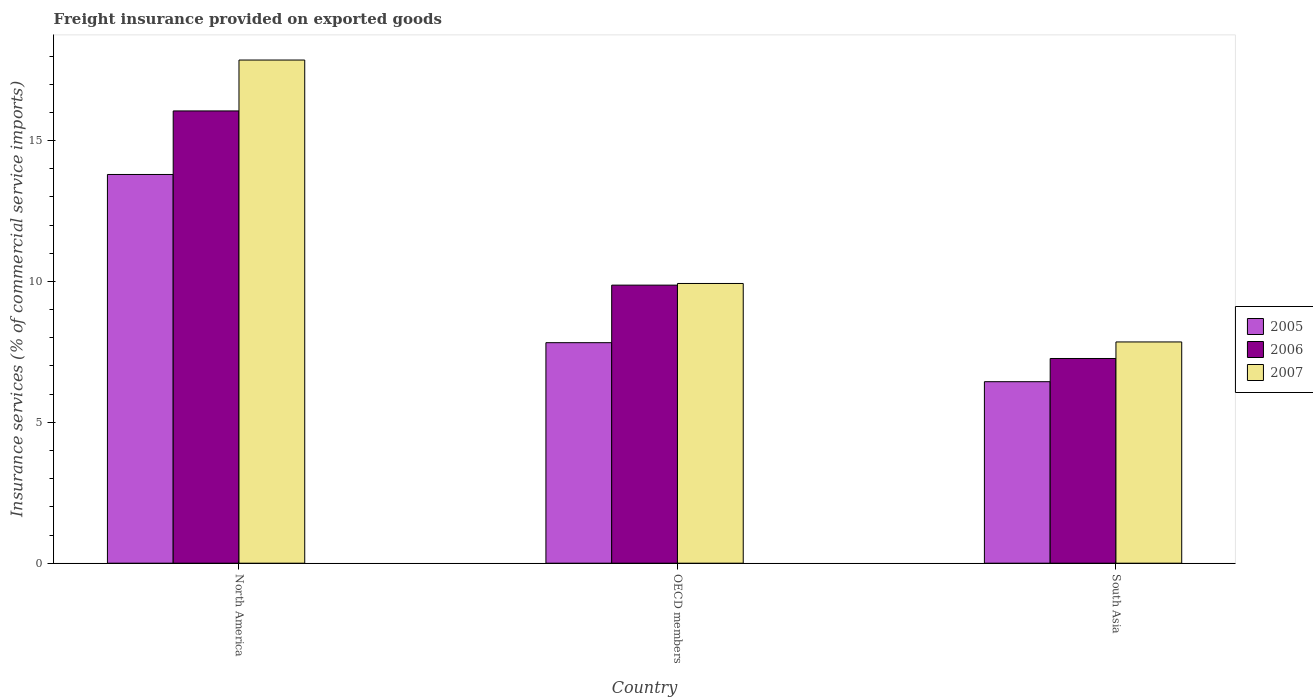How many different coloured bars are there?
Give a very brief answer. 3. Are the number of bars on each tick of the X-axis equal?
Ensure brevity in your answer.  Yes. In how many cases, is the number of bars for a given country not equal to the number of legend labels?
Provide a short and direct response. 0. What is the freight insurance provided on exported goods in 2005 in OECD members?
Offer a terse response. 7.83. Across all countries, what is the maximum freight insurance provided on exported goods in 2006?
Offer a terse response. 16.05. Across all countries, what is the minimum freight insurance provided on exported goods in 2006?
Offer a very short reply. 7.27. In which country was the freight insurance provided on exported goods in 2006 maximum?
Your answer should be very brief. North America. What is the total freight insurance provided on exported goods in 2006 in the graph?
Offer a very short reply. 33.19. What is the difference between the freight insurance provided on exported goods in 2006 in North America and that in OECD members?
Provide a short and direct response. 6.18. What is the difference between the freight insurance provided on exported goods in 2006 in North America and the freight insurance provided on exported goods in 2005 in South Asia?
Your answer should be very brief. 9.61. What is the average freight insurance provided on exported goods in 2005 per country?
Ensure brevity in your answer.  9.36. What is the difference between the freight insurance provided on exported goods of/in 2006 and freight insurance provided on exported goods of/in 2007 in South Asia?
Provide a short and direct response. -0.59. What is the ratio of the freight insurance provided on exported goods in 2005 in North America to that in OECD members?
Give a very brief answer. 1.76. Is the freight insurance provided on exported goods in 2005 in OECD members less than that in South Asia?
Your response must be concise. No. Is the difference between the freight insurance provided on exported goods in 2006 in North America and OECD members greater than the difference between the freight insurance provided on exported goods in 2007 in North America and OECD members?
Provide a short and direct response. No. What is the difference between the highest and the second highest freight insurance provided on exported goods in 2007?
Offer a terse response. 7.93. What is the difference between the highest and the lowest freight insurance provided on exported goods in 2007?
Keep it short and to the point. 10.01. In how many countries, is the freight insurance provided on exported goods in 2005 greater than the average freight insurance provided on exported goods in 2005 taken over all countries?
Provide a succinct answer. 1. What does the 1st bar from the left in North America represents?
Give a very brief answer. 2005. What does the 2nd bar from the right in South Asia represents?
Your answer should be very brief. 2006. Is it the case that in every country, the sum of the freight insurance provided on exported goods in 2006 and freight insurance provided on exported goods in 2005 is greater than the freight insurance provided on exported goods in 2007?
Provide a short and direct response. Yes. How many bars are there?
Ensure brevity in your answer.  9. Are all the bars in the graph horizontal?
Offer a terse response. No. What is the title of the graph?
Provide a short and direct response. Freight insurance provided on exported goods. Does "1976" appear as one of the legend labels in the graph?
Provide a short and direct response. No. What is the label or title of the Y-axis?
Offer a terse response. Insurance services (% of commercial service imports). What is the Insurance services (% of commercial service imports) of 2005 in North America?
Offer a terse response. 13.8. What is the Insurance services (% of commercial service imports) of 2006 in North America?
Offer a very short reply. 16.05. What is the Insurance services (% of commercial service imports) of 2007 in North America?
Your response must be concise. 17.86. What is the Insurance services (% of commercial service imports) in 2005 in OECD members?
Make the answer very short. 7.83. What is the Insurance services (% of commercial service imports) in 2006 in OECD members?
Ensure brevity in your answer.  9.87. What is the Insurance services (% of commercial service imports) in 2007 in OECD members?
Offer a terse response. 9.93. What is the Insurance services (% of commercial service imports) of 2005 in South Asia?
Offer a very short reply. 6.44. What is the Insurance services (% of commercial service imports) of 2006 in South Asia?
Your answer should be compact. 7.27. What is the Insurance services (% of commercial service imports) in 2007 in South Asia?
Your answer should be very brief. 7.85. Across all countries, what is the maximum Insurance services (% of commercial service imports) in 2005?
Keep it short and to the point. 13.8. Across all countries, what is the maximum Insurance services (% of commercial service imports) in 2006?
Ensure brevity in your answer.  16.05. Across all countries, what is the maximum Insurance services (% of commercial service imports) of 2007?
Provide a short and direct response. 17.86. Across all countries, what is the minimum Insurance services (% of commercial service imports) in 2005?
Your answer should be compact. 6.44. Across all countries, what is the minimum Insurance services (% of commercial service imports) in 2006?
Your response must be concise. 7.27. Across all countries, what is the minimum Insurance services (% of commercial service imports) of 2007?
Your answer should be very brief. 7.85. What is the total Insurance services (% of commercial service imports) of 2005 in the graph?
Ensure brevity in your answer.  28.07. What is the total Insurance services (% of commercial service imports) of 2006 in the graph?
Provide a short and direct response. 33.19. What is the total Insurance services (% of commercial service imports) in 2007 in the graph?
Keep it short and to the point. 35.64. What is the difference between the Insurance services (% of commercial service imports) of 2005 in North America and that in OECD members?
Make the answer very short. 5.97. What is the difference between the Insurance services (% of commercial service imports) in 2006 in North America and that in OECD members?
Make the answer very short. 6.18. What is the difference between the Insurance services (% of commercial service imports) of 2007 in North America and that in OECD members?
Your answer should be very brief. 7.93. What is the difference between the Insurance services (% of commercial service imports) in 2005 in North America and that in South Asia?
Offer a very short reply. 7.35. What is the difference between the Insurance services (% of commercial service imports) of 2006 in North America and that in South Asia?
Make the answer very short. 8.79. What is the difference between the Insurance services (% of commercial service imports) of 2007 in North America and that in South Asia?
Keep it short and to the point. 10.01. What is the difference between the Insurance services (% of commercial service imports) in 2005 in OECD members and that in South Asia?
Your answer should be very brief. 1.38. What is the difference between the Insurance services (% of commercial service imports) of 2006 in OECD members and that in South Asia?
Your answer should be very brief. 2.6. What is the difference between the Insurance services (% of commercial service imports) of 2007 in OECD members and that in South Asia?
Ensure brevity in your answer.  2.08. What is the difference between the Insurance services (% of commercial service imports) of 2005 in North America and the Insurance services (% of commercial service imports) of 2006 in OECD members?
Keep it short and to the point. 3.93. What is the difference between the Insurance services (% of commercial service imports) of 2005 in North America and the Insurance services (% of commercial service imports) of 2007 in OECD members?
Your answer should be compact. 3.87. What is the difference between the Insurance services (% of commercial service imports) in 2006 in North America and the Insurance services (% of commercial service imports) in 2007 in OECD members?
Make the answer very short. 6.12. What is the difference between the Insurance services (% of commercial service imports) in 2005 in North America and the Insurance services (% of commercial service imports) in 2006 in South Asia?
Make the answer very short. 6.53. What is the difference between the Insurance services (% of commercial service imports) in 2005 in North America and the Insurance services (% of commercial service imports) in 2007 in South Asia?
Provide a succinct answer. 5.94. What is the difference between the Insurance services (% of commercial service imports) of 2006 in North America and the Insurance services (% of commercial service imports) of 2007 in South Asia?
Your answer should be very brief. 8.2. What is the difference between the Insurance services (% of commercial service imports) of 2005 in OECD members and the Insurance services (% of commercial service imports) of 2006 in South Asia?
Offer a terse response. 0.56. What is the difference between the Insurance services (% of commercial service imports) in 2005 in OECD members and the Insurance services (% of commercial service imports) in 2007 in South Asia?
Give a very brief answer. -0.03. What is the difference between the Insurance services (% of commercial service imports) of 2006 in OECD members and the Insurance services (% of commercial service imports) of 2007 in South Asia?
Give a very brief answer. 2.02. What is the average Insurance services (% of commercial service imports) in 2005 per country?
Your response must be concise. 9.36. What is the average Insurance services (% of commercial service imports) of 2006 per country?
Provide a short and direct response. 11.06. What is the average Insurance services (% of commercial service imports) of 2007 per country?
Offer a very short reply. 11.88. What is the difference between the Insurance services (% of commercial service imports) in 2005 and Insurance services (% of commercial service imports) in 2006 in North America?
Your answer should be very brief. -2.26. What is the difference between the Insurance services (% of commercial service imports) in 2005 and Insurance services (% of commercial service imports) in 2007 in North America?
Your response must be concise. -4.06. What is the difference between the Insurance services (% of commercial service imports) of 2006 and Insurance services (% of commercial service imports) of 2007 in North America?
Your answer should be compact. -1.81. What is the difference between the Insurance services (% of commercial service imports) in 2005 and Insurance services (% of commercial service imports) in 2006 in OECD members?
Provide a short and direct response. -2.04. What is the difference between the Insurance services (% of commercial service imports) in 2005 and Insurance services (% of commercial service imports) in 2007 in OECD members?
Provide a short and direct response. -2.1. What is the difference between the Insurance services (% of commercial service imports) of 2006 and Insurance services (% of commercial service imports) of 2007 in OECD members?
Make the answer very short. -0.06. What is the difference between the Insurance services (% of commercial service imports) of 2005 and Insurance services (% of commercial service imports) of 2006 in South Asia?
Offer a very short reply. -0.82. What is the difference between the Insurance services (% of commercial service imports) of 2005 and Insurance services (% of commercial service imports) of 2007 in South Asia?
Your answer should be compact. -1.41. What is the difference between the Insurance services (% of commercial service imports) in 2006 and Insurance services (% of commercial service imports) in 2007 in South Asia?
Your answer should be very brief. -0.59. What is the ratio of the Insurance services (% of commercial service imports) of 2005 in North America to that in OECD members?
Ensure brevity in your answer.  1.76. What is the ratio of the Insurance services (% of commercial service imports) in 2006 in North America to that in OECD members?
Give a very brief answer. 1.63. What is the ratio of the Insurance services (% of commercial service imports) of 2007 in North America to that in OECD members?
Give a very brief answer. 1.8. What is the ratio of the Insurance services (% of commercial service imports) of 2005 in North America to that in South Asia?
Your response must be concise. 2.14. What is the ratio of the Insurance services (% of commercial service imports) in 2006 in North America to that in South Asia?
Offer a terse response. 2.21. What is the ratio of the Insurance services (% of commercial service imports) of 2007 in North America to that in South Asia?
Offer a terse response. 2.27. What is the ratio of the Insurance services (% of commercial service imports) of 2005 in OECD members to that in South Asia?
Offer a very short reply. 1.21. What is the ratio of the Insurance services (% of commercial service imports) in 2006 in OECD members to that in South Asia?
Offer a very short reply. 1.36. What is the ratio of the Insurance services (% of commercial service imports) in 2007 in OECD members to that in South Asia?
Offer a very short reply. 1.26. What is the difference between the highest and the second highest Insurance services (% of commercial service imports) of 2005?
Your answer should be compact. 5.97. What is the difference between the highest and the second highest Insurance services (% of commercial service imports) in 2006?
Provide a short and direct response. 6.18. What is the difference between the highest and the second highest Insurance services (% of commercial service imports) of 2007?
Make the answer very short. 7.93. What is the difference between the highest and the lowest Insurance services (% of commercial service imports) in 2005?
Make the answer very short. 7.35. What is the difference between the highest and the lowest Insurance services (% of commercial service imports) in 2006?
Make the answer very short. 8.79. What is the difference between the highest and the lowest Insurance services (% of commercial service imports) in 2007?
Give a very brief answer. 10.01. 